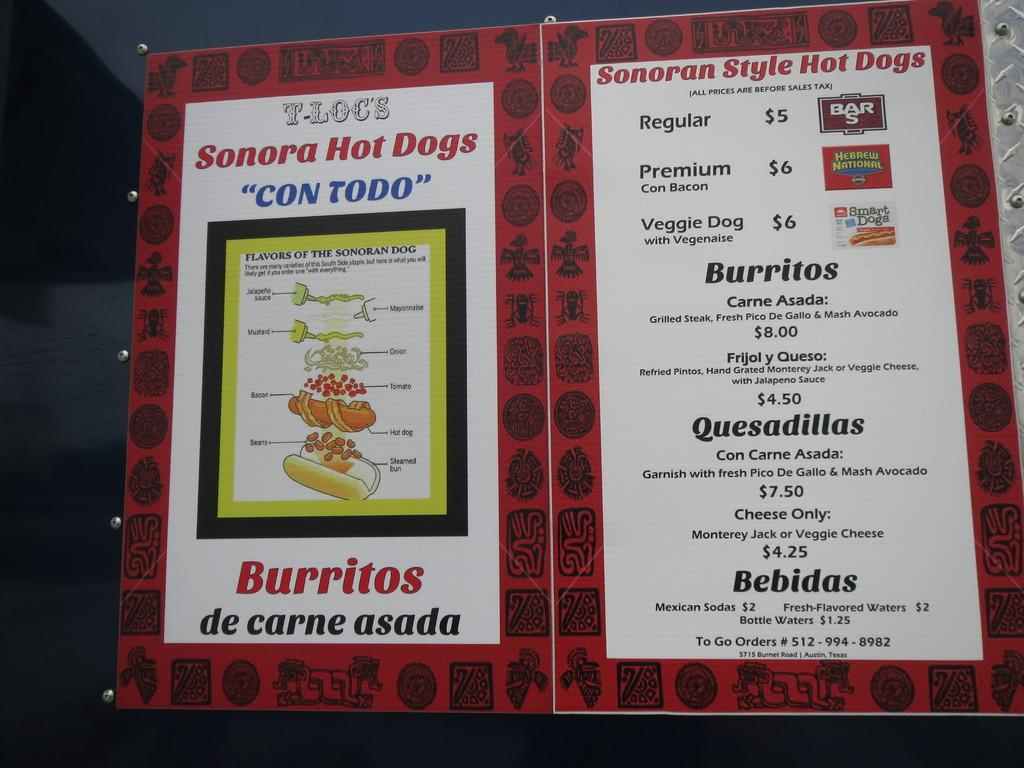<image>
Offer a succinct explanation of the picture presented. Menu for Sonora Hot dogs and also sells burritos as well. 